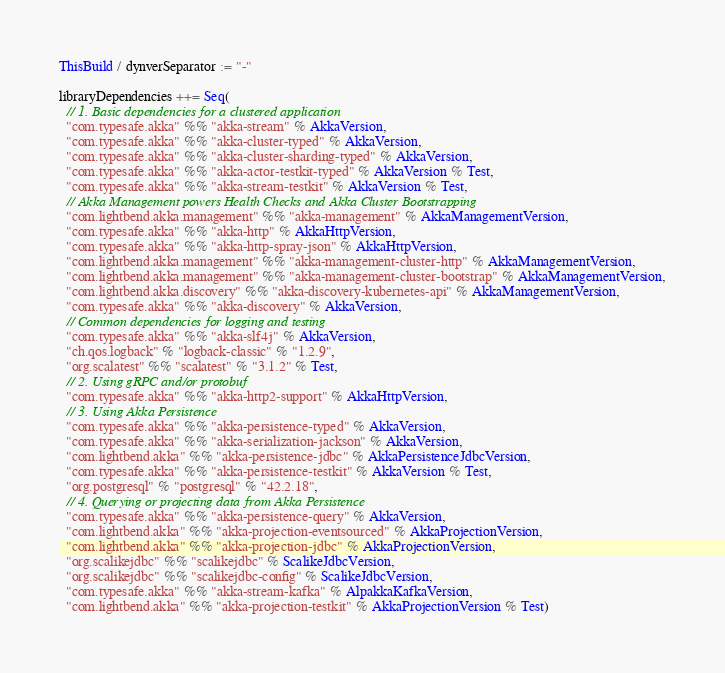Convert code to text. <code><loc_0><loc_0><loc_500><loc_500><_Scala_>ThisBuild / dynverSeparator := "-"

libraryDependencies ++= Seq(
  // 1. Basic dependencies for a clustered application
  "com.typesafe.akka" %% "akka-stream" % AkkaVersion,
  "com.typesafe.akka" %% "akka-cluster-typed" % AkkaVersion,
  "com.typesafe.akka" %% "akka-cluster-sharding-typed" % AkkaVersion,
  "com.typesafe.akka" %% "akka-actor-testkit-typed" % AkkaVersion % Test,
  "com.typesafe.akka" %% "akka-stream-testkit" % AkkaVersion % Test,
  // Akka Management powers Health Checks and Akka Cluster Bootstrapping
  "com.lightbend.akka.management" %% "akka-management" % AkkaManagementVersion,
  "com.typesafe.akka" %% "akka-http" % AkkaHttpVersion,
  "com.typesafe.akka" %% "akka-http-spray-json" % AkkaHttpVersion,
  "com.lightbend.akka.management" %% "akka-management-cluster-http" % AkkaManagementVersion,
  "com.lightbend.akka.management" %% "akka-management-cluster-bootstrap" % AkkaManagementVersion,
  "com.lightbend.akka.discovery" %% "akka-discovery-kubernetes-api" % AkkaManagementVersion,
  "com.typesafe.akka" %% "akka-discovery" % AkkaVersion,
  // Common dependencies for logging and testing
  "com.typesafe.akka" %% "akka-slf4j" % AkkaVersion,
  "ch.qos.logback" % "logback-classic" % "1.2.9",
  "org.scalatest" %% "scalatest" % "3.1.2" % Test,
  // 2. Using gRPC and/or protobuf
  "com.typesafe.akka" %% "akka-http2-support" % AkkaHttpVersion,
  // 3. Using Akka Persistence
  "com.typesafe.akka" %% "akka-persistence-typed" % AkkaVersion,
  "com.typesafe.akka" %% "akka-serialization-jackson" % AkkaVersion,
  "com.lightbend.akka" %% "akka-persistence-jdbc" % AkkaPersistenceJdbcVersion,
  "com.typesafe.akka" %% "akka-persistence-testkit" % AkkaVersion % Test,
  "org.postgresql" % "postgresql" % "42.2.18",
  // 4. Querying or projecting data from Akka Persistence
  "com.typesafe.akka" %% "akka-persistence-query" % AkkaVersion,
  "com.lightbend.akka" %% "akka-projection-eventsourced" % AkkaProjectionVersion,
  "com.lightbend.akka" %% "akka-projection-jdbc" % AkkaProjectionVersion,
  "org.scalikejdbc" %% "scalikejdbc" % ScalikeJdbcVersion,
  "org.scalikejdbc" %% "scalikejdbc-config" % ScalikeJdbcVersion,
  "com.typesafe.akka" %% "akka-stream-kafka" % AlpakkaKafkaVersion,
  "com.lightbend.akka" %% "akka-projection-testkit" % AkkaProjectionVersion % Test)
</code> 